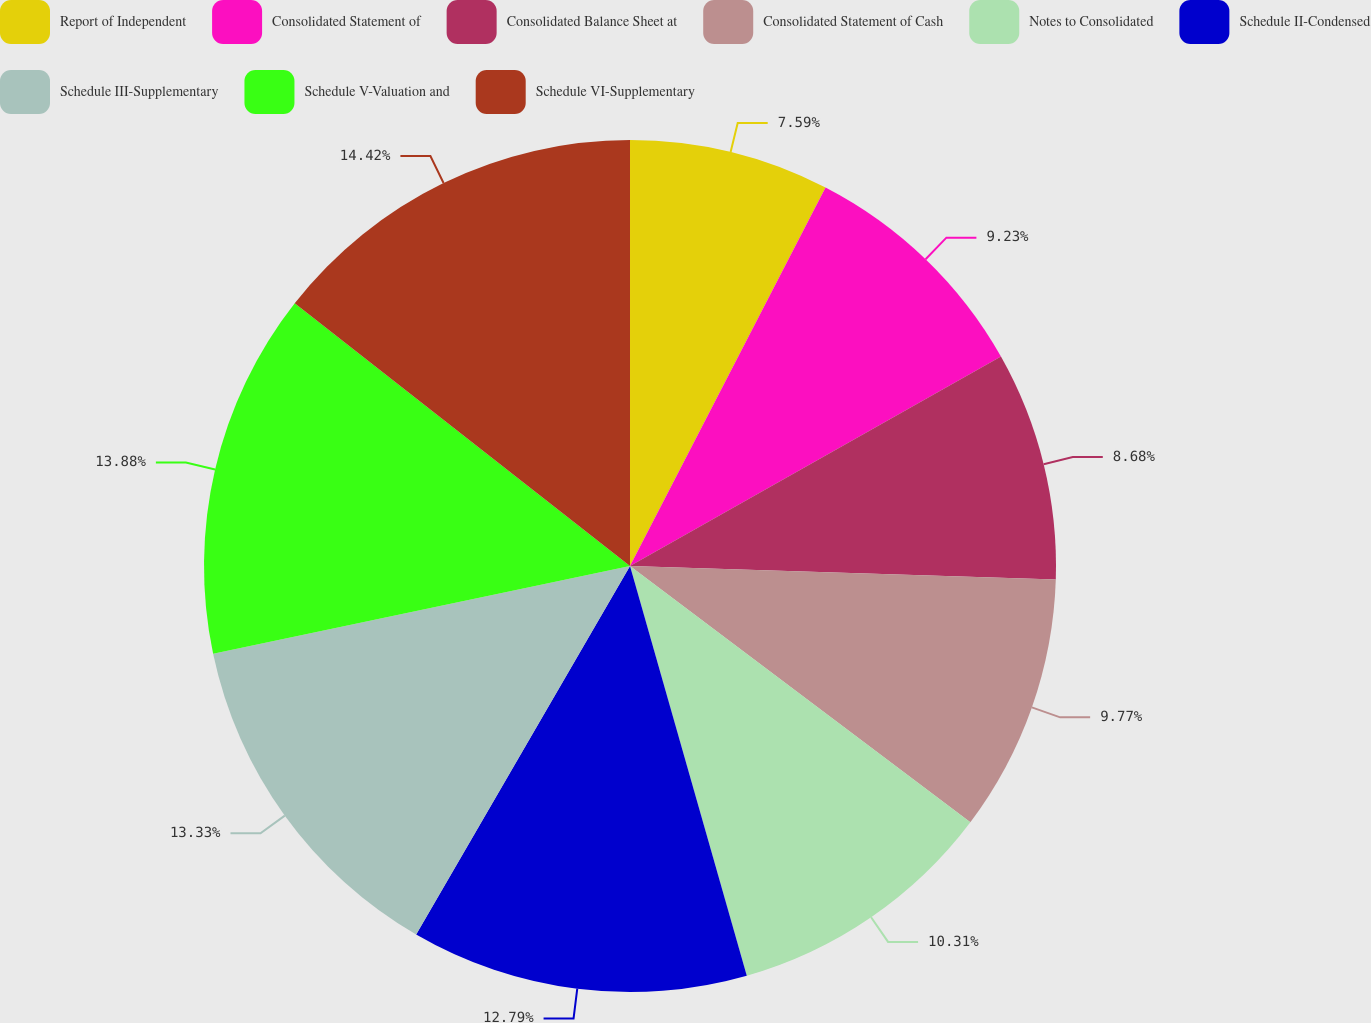<chart> <loc_0><loc_0><loc_500><loc_500><pie_chart><fcel>Report of Independent<fcel>Consolidated Statement of<fcel>Consolidated Balance Sheet at<fcel>Consolidated Statement of Cash<fcel>Notes to Consolidated<fcel>Schedule II-Condensed<fcel>Schedule III-Supplementary<fcel>Schedule V-Valuation and<fcel>Schedule VI-Supplementary<nl><fcel>7.59%<fcel>9.23%<fcel>8.68%<fcel>9.77%<fcel>10.31%<fcel>12.79%<fcel>13.33%<fcel>13.88%<fcel>14.42%<nl></chart> 